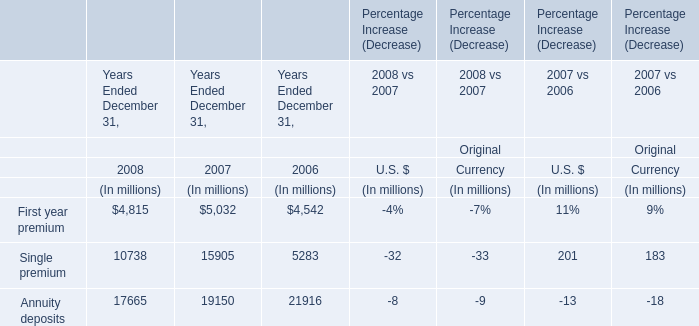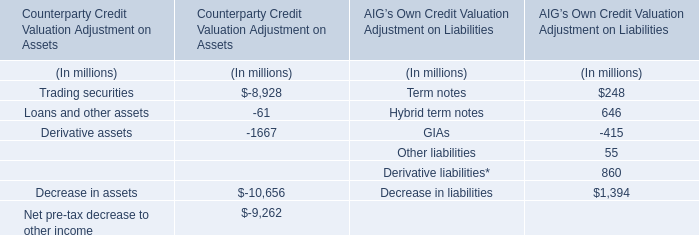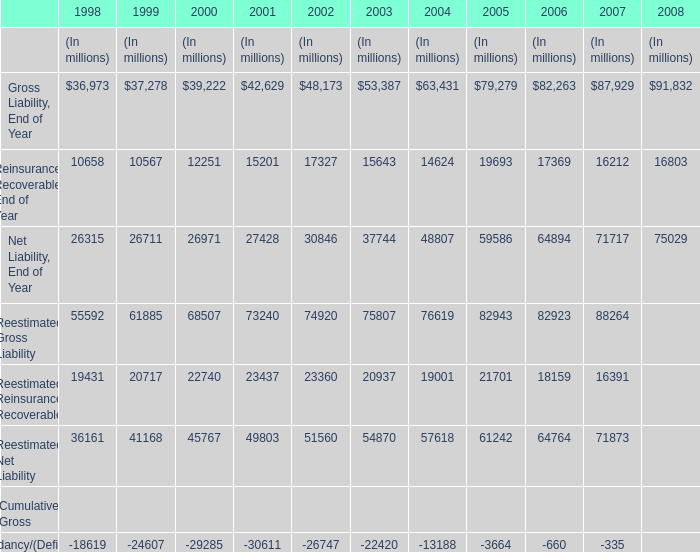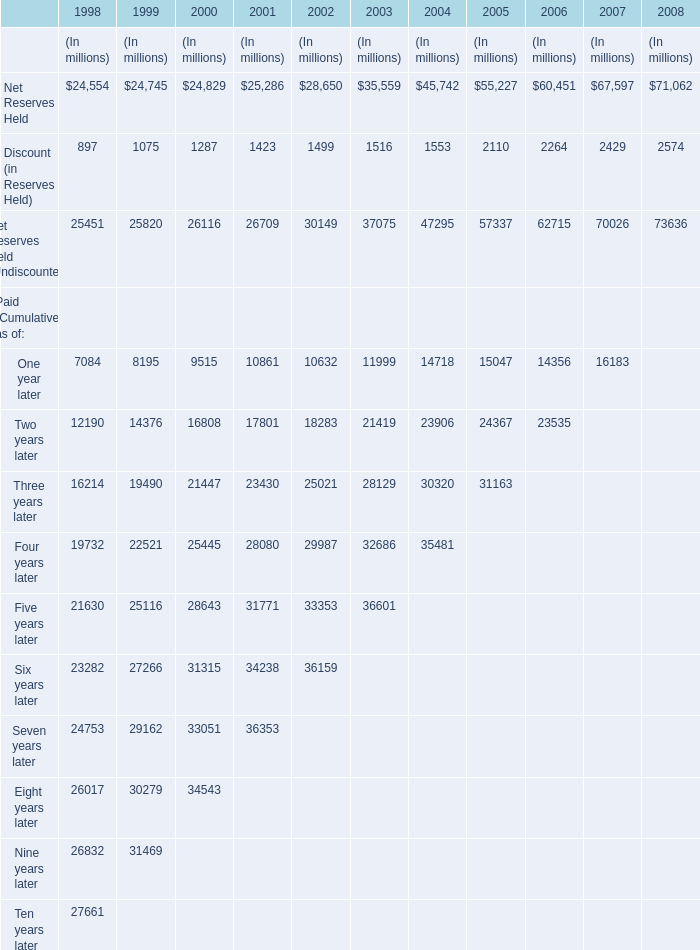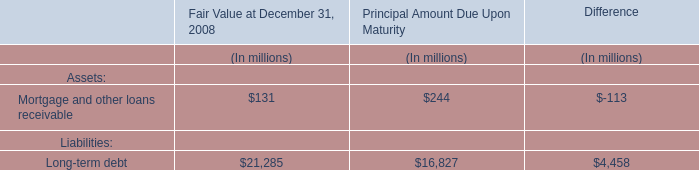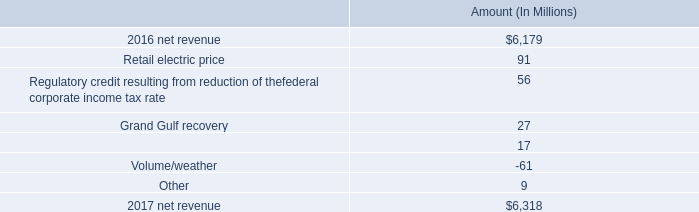If Net Reserves Held develops with the same increasing rate in 1999, what will it reach in 2000? (in million) 
Computations: (24745 + ((24745 * (24745 - 24554)) / 24554))
Answer: 24937.48575. 